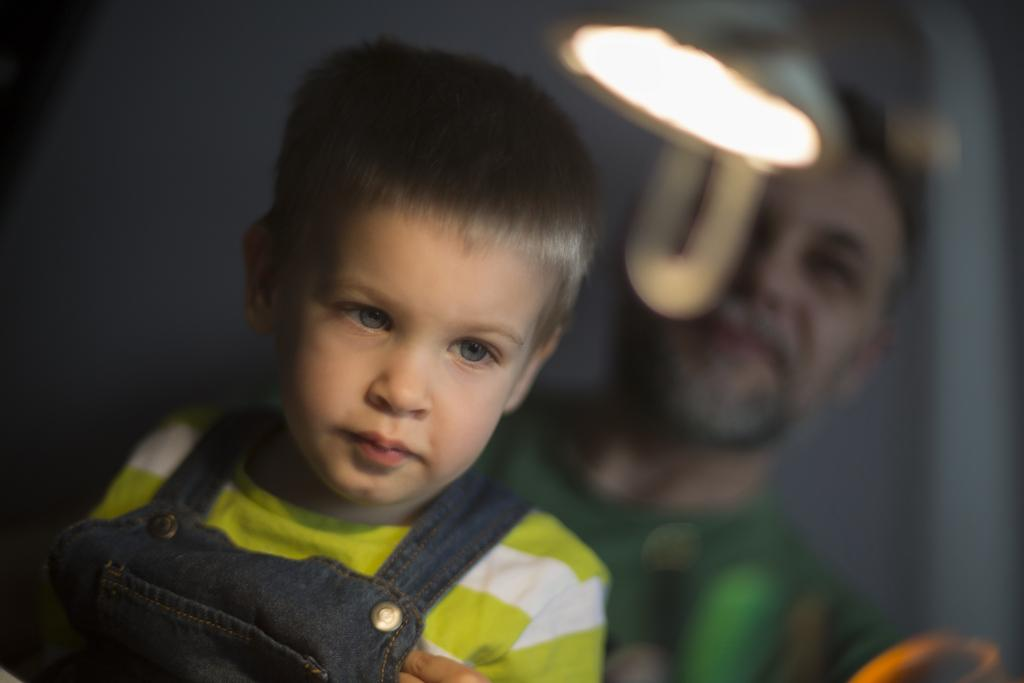Who are the people in the image? There is a man and a boy in the image. What can be seen in the image besides the people? There is a light visible in the image. How would you describe the background of the image? The background of the image is blurry. How many geese are flying in the background of the image? There are no geese present in the image; the background is blurry. 